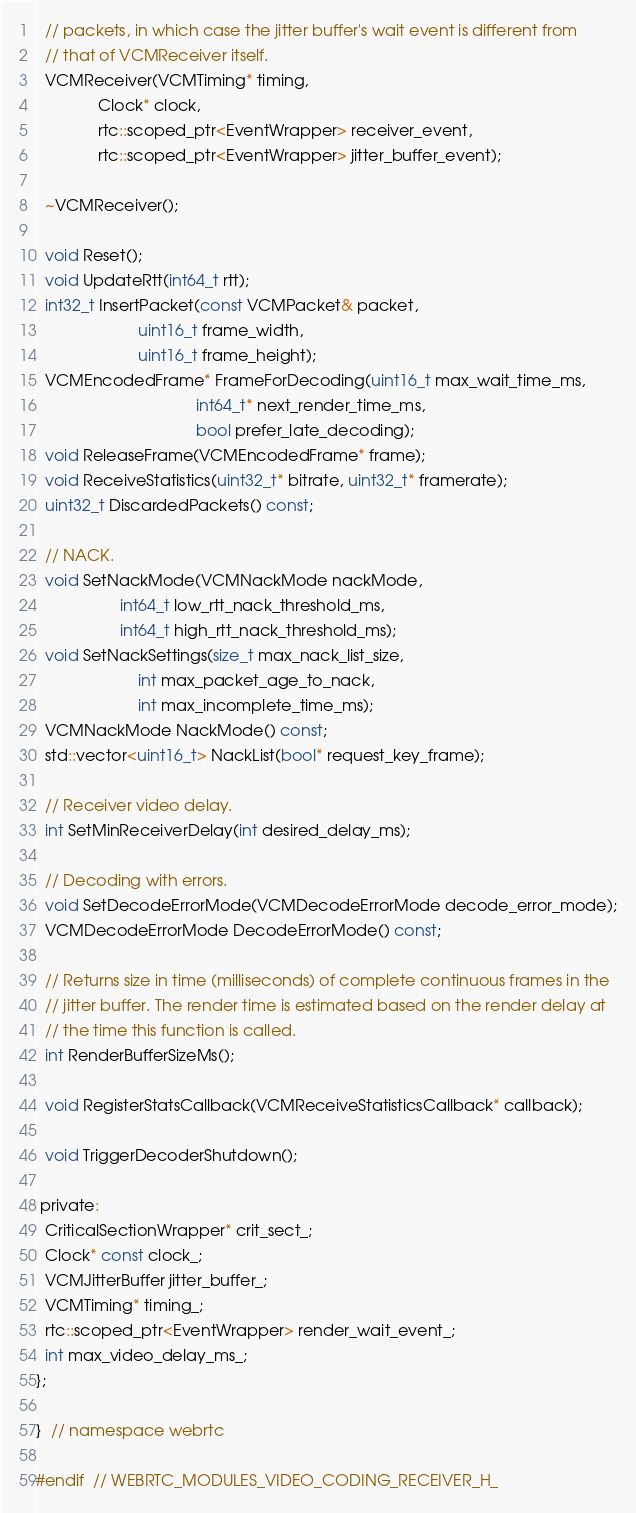<code> <loc_0><loc_0><loc_500><loc_500><_C_>  // packets, in which case the jitter buffer's wait event is different from
  // that of VCMReceiver itself.
  VCMReceiver(VCMTiming* timing,
              Clock* clock,
              rtc::scoped_ptr<EventWrapper> receiver_event,
              rtc::scoped_ptr<EventWrapper> jitter_buffer_event);

  ~VCMReceiver();

  void Reset();
  void UpdateRtt(int64_t rtt);
  int32_t InsertPacket(const VCMPacket& packet,
                       uint16_t frame_width,
                       uint16_t frame_height);
  VCMEncodedFrame* FrameForDecoding(uint16_t max_wait_time_ms,
                                    int64_t* next_render_time_ms,
                                    bool prefer_late_decoding);
  void ReleaseFrame(VCMEncodedFrame* frame);
  void ReceiveStatistics(uint32_t* bitrate, uint32_t* framerate);
  uint32_t DiscardedPackets() const;

  // NACK.
  void SetNackMode(VCMNackMode nackMode,
                   int64_t low_rtt_nack_threshold_ms,
                   int64_t high_rtt_nack_threshold_ms);
  void SetNackSettings(size_t max_nack_list_size,
                       int max_packet_age_to_nack,
                       int max_incomplete_time_ms);
  VCMNackMode NackMode() const;
  std::vector<uint16_t> NackList(bool* request_key_frame);

  // Receiver video delay.
  int SetMinReceiverDelay(int desired_delay_ms);

  // Decoding with errors.
  void SetDecodeErrorMode(VCMDecodeErrorMode decode_error_mode);
  VCMDecodeErrorMode DecodeErrorMode() const;

  // Returns size in time (milliseconds) of complete continuous frames in the
  // jitter buffer. The render time is estimated based on the render delay at
  // the time this function is called.
  int RenderBufferSizeMs();

  void RegisterStatsCallback(VCMReceiveStatisticsCallback* callback);

  void TriggerDecoderShutdown();

 private:
  CriticalSectionWrapper* crit_sect_;
  Clock* const clock_;
  VCMJitterBuffer jitter_buffer_;
  VCMTiming* timing_;
  rtc::scoped_ptr<EventWrapper> render_wait_event_;
  int max_video_delay_ms_;
};

}  // namespace webrtc

#endif  // WEBRTC_MODULES_VIDEO_CODING_RECEIVER_H_
</code> 